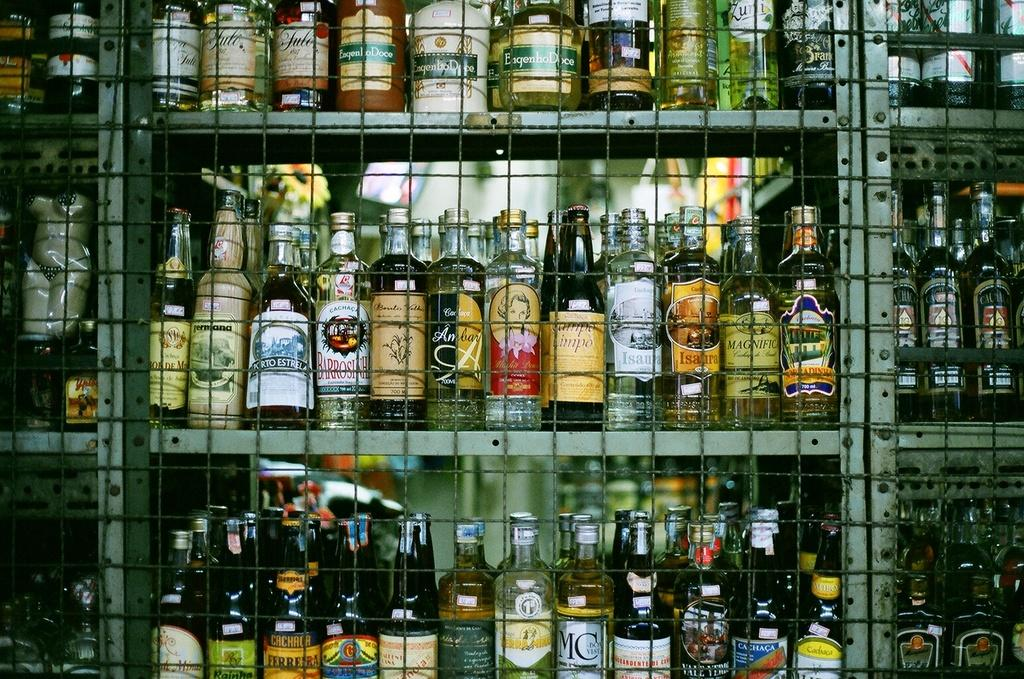<image>
Give a short and clear explanation of the subsequent image. Many bottles of alcohol, including Isaura, are behind a caged wall. 